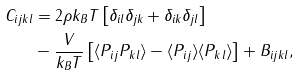<formula> <loc_0><loc_0><loc_500><loc_500>C _ { i j k l } & = 2 \rho k _ { B } T \left [ \delta _ { i l } \delta _ { j k } + \delta _ { i k } \delta _ { j l } \right ] \\ & - \frac { V } { k _ { B } T } \left [ \langle P _ { i j } P _ { k l } \rangle - \langle P _ { i j } \rangle \langle P _ { k l } \rangle \right ] + B _ { i j k l } ,</formula> 